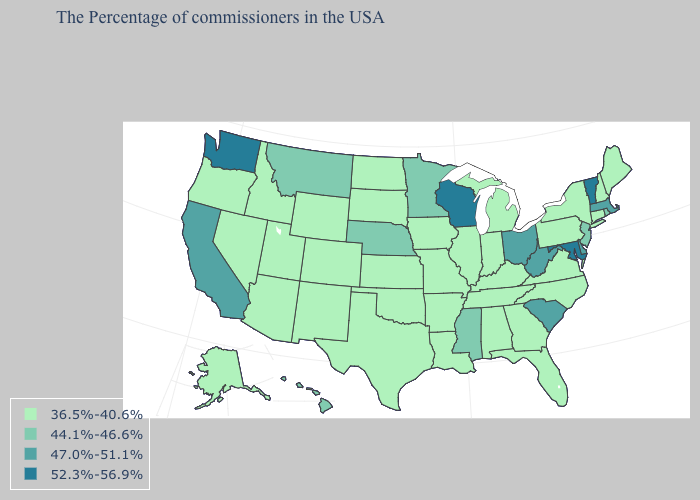Does the map have missing data?
Concise answer only. No. Name the states that have a value in the range 44.1%-46.6%?
Answer briefly. Rhode Island, New Jersey, Mississippi, Minnesota, Nebraska, Montana, Hawaii. What is the value of North Dakota?
Be succinct. 36.5%-40.6%. Does Rhode Island have the same value as Ohio?
Answer briefly. No. Among the states that border Virginia , which have the lowest value?
Keep it brief. North Carolina, Kentucky, Tennessee. What is the value of Hawaii?
Concise answer only. 44.1%-46.6%. What is the lowest value in the MidWest?
Write a very short answer. 36.5%-40.6%. What is the value of Texas?
Keep it brief. 36.5%-40.6%. What is the value of New Jersey?
Give a very brief answer. 44.1%-46.6%. What is the lowest value in states that border Minnesota?
Concise answer only. 36.5%-40.6%. Name the states that have a value in the range 44.1%-46.6%?
Quick response, please. Rhode Island, New Jersey, Mississippi, Minnesota, Nebraska, Montana, Hawaii. Does Connecticut have the lowest value in the USA?
Keep it brief. Yes. Among the states that border Utah , which have the lowest value?
Give a very brief answer. Wyoming, Colorado, New Mexico, Arizona, Idaho, Nevada. What is the lowest value in the West?
Quick response, please. 36.5%-40.6%. Which states have the lowest value in the USA?
Be succinct. Maine, New Hampshire, Connecticut, New York, Pennsylvania, Virginia, North Carolina, Florida, Georgia, Michigan, Kentucky, Indiana, Alabama, Tennessee, Illinois, Louisiana, Missouri, Arkansas, Iowa, Kansas, Oklahoma, Texas, South Dakota, North Dakota, Wyoming, Colorado, New Mexico, Utah, Arizona, Idaho, Nevada, Oregon, Alaska. 